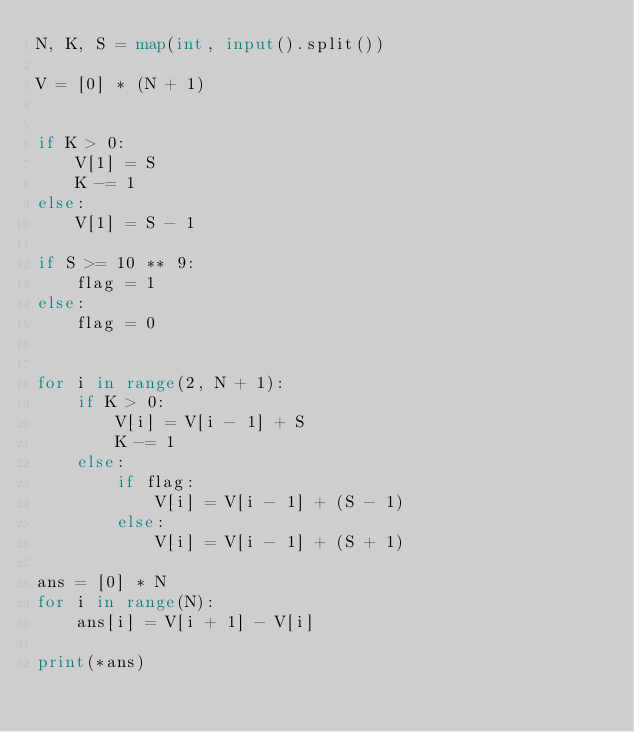Convert code to text. <code><loc_0><loc_0><loc_500><loc_500><_Python_>N, K, S = map(int, input().split())

V = [0] * (N + 1)


if K > 0:
    V[1] = S
    K -= 1
else:
    V[1] = S - 1

if S >= 10 ** 9:
    flag = 1
else:
    flag = 0


for i in range(2, N + 1):
    if K > 0:
        V[i] = V[i - 1] + S
        K -= 1
    else:
        if flag:
            V[i] = V[i - 1] + (S - 1)
        else:
            V[i] = V[i - 1] + (S + 1)

ans = [0] * N
for i in range(N):
    ans[i] = V[i + 1] - V[i]

print(*ans)
</code> 